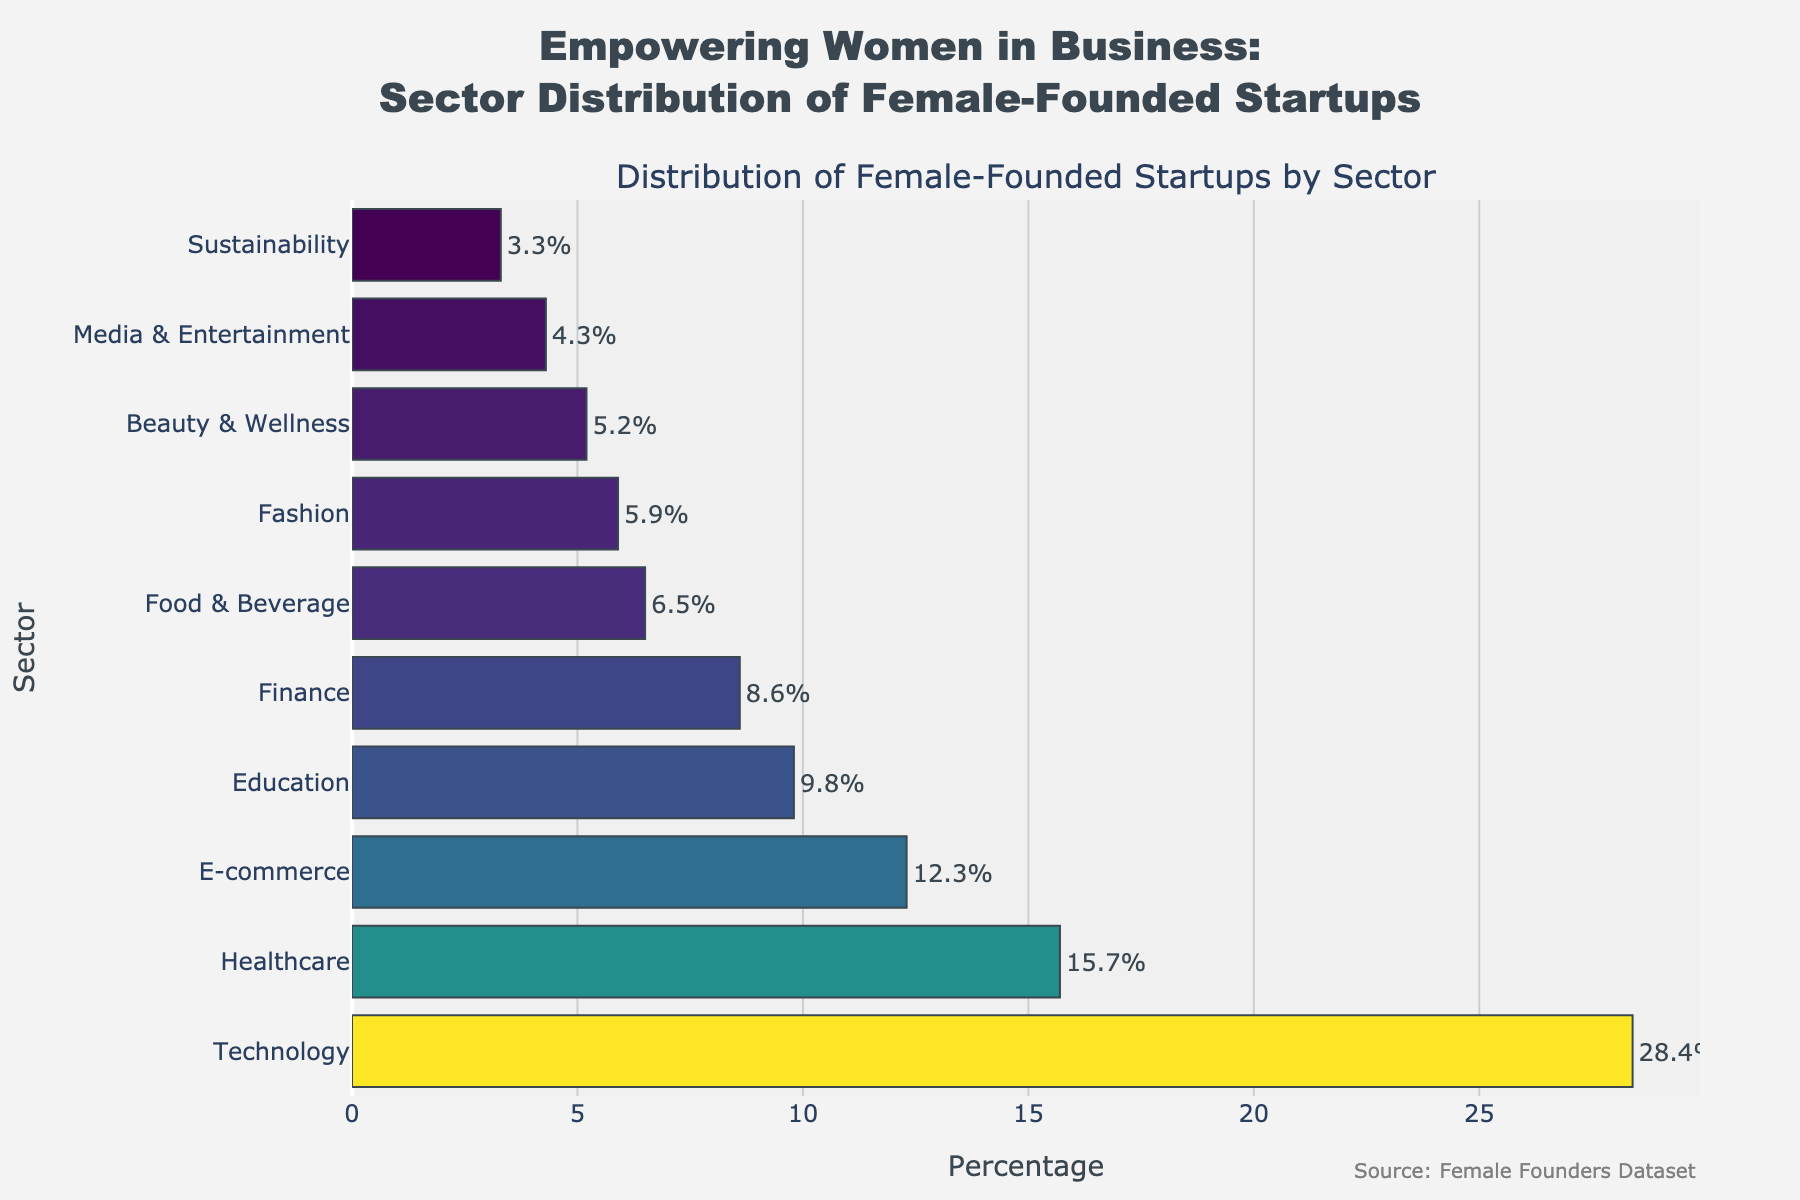What is the sector with the highest percentage of female-founded startups? The highest percentage bar visually corresponds to the Technology sector.
Answer: Technology What's the difference in percentage between the Technology and Healthcare sectors? The Technology sector is at 28.4% and the Healthcare sector is at 15.7%. Subtract 15.7 from 28.4 to get the difference, which is 12.7%.
Answer: 12.7% How many sectors have a percentage of female-founded startups above 10%? Technology, Healthcare, and E-commerce have percentages above 10%. In total, there are 3 sectors.
Answer: 3 Which sector has a higher percentage of female-founded startups, Media & Entertainment or Finance? By comparing the bars, Finance (8.6%) has a higher percentage than Media & Entertainment (4.3%).
Answer: Finance What's the combined percentage of female-founded startups in E-commerce and Education sectors? E-commerce has 12.3% and Education has 9.8%. Add these two percentages, 12.3 + 9.8 = 22.1%.
Answer: 22.1% What is the least represented sector for female-founded startups? The Sustainability sector has the smallest bar, indicating 3.3%, which is the lowest.
Answer: Sustainability Arrange the sectors in ascending order of their percentages of female-founded startups. Sorting the percentages: Sustainability (3.3%), Media & Entertainment (4.3%), Beauty & Wellness (5.2%), Fashion (5.9%), Food & Beverage (6.5%), Finance (8.6%), Education (9.8%), E-commerce (12.3%), Healthcare (15.7%), Technology (28.4%).
Answer: Sustainability, Media & Entertainment, Beauty & Wellness, Fashion, Food & Beverage, Finance, Education, E-commerce, Healthcare, Technology What percentage of female-founded startups falls into Fashion, Beauty & Wellness, and Media & Entertainment sectors combined? Add the percentages for Fashion (5.9%), Beauty & Wellness (5.2%), and Media & Entertainment (4.3%): 5.9 + 5.2 + 4.3 = 15.4%.
Answer: 15.4% Which sector shows nearly half the percentage of female-founded startups compared to Technology? Healthcare has 15.7%, which is about half of Technology's 28.4%.
Answer: Healthcare 